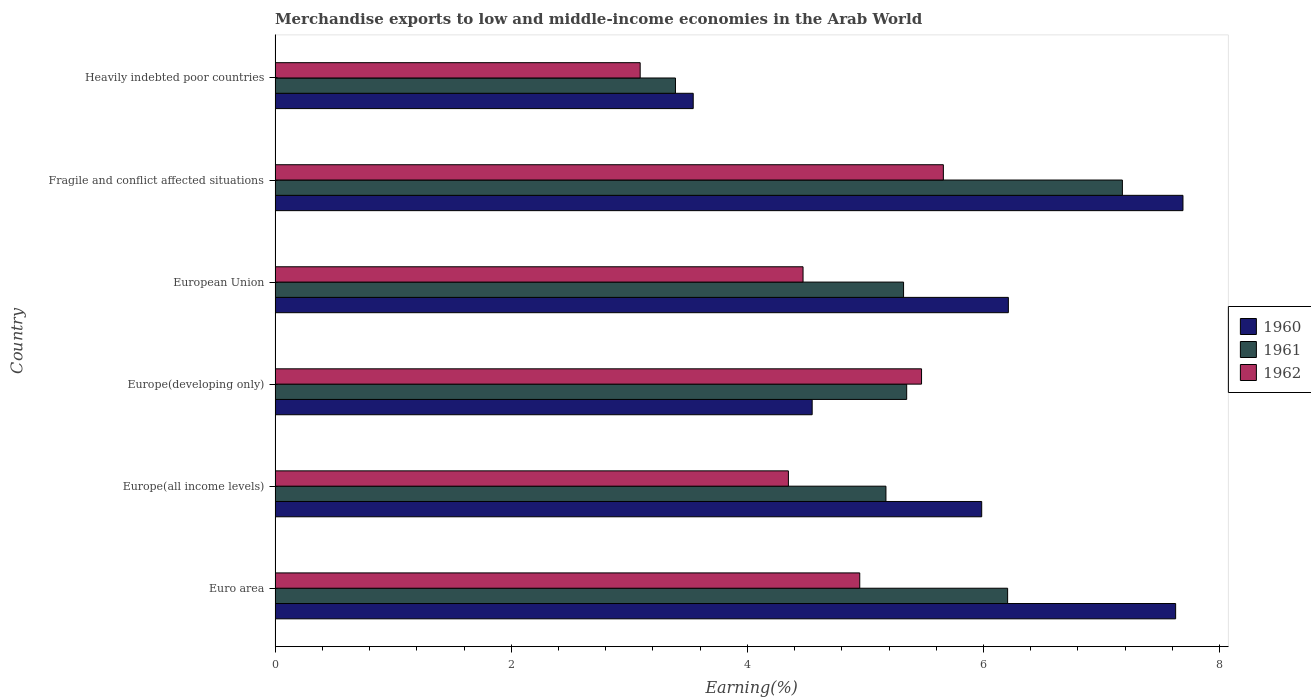How many different coloured bars are there?
Offer a terse response. 3. Are the number of bars per tick equal to the number of legend labels?
Provide a short and direct response. Yes. How many bars are there on the 1st tick from the bottom?
Keep it short and to the point. 3. What is the label of the 4th group of bars from the top?
Provide a succinct answer. Europe(developing only). In how many cases, is the number of bars for a given country not equal to the number of legend labels?
Provide a short and direct response. 0. What is the percentage of amount earned from merchandise exports in 1961 in Europe(all income levels)?
Your response must be concise. 5.17. Across all countries, what is the maximum percentage of amount earned from merchandise exports in 1961?
Keep it short and to the point. 7.18. Across all countries, what is the minimum percentage of amount earned from merchandise exports in 1960?
Offer a very short reply. 3.54. In which country was the percentage of amount earned from merchandise exports in 1960 maximum?
Your response must be concise. Fragile and conflict affected situations. In which country was the percentage of amount earned from merchandise exports in 1962 minimum?
Keep it short and to the point. Heavily indebted poor countries. What is the total percentage of amount earned from merchandise exports in 1962 in the graph?
Your response must be concise. 28. What is the difference between the percentage of amount earned from merchandise exports in 1960 in Euro area and that in Fragile and conflict affected situations?
Your answer should be very brief. -0.06. What is the difference between the percentage of amount earned from merchandise exports in 1962 in Euro area and the percentage of amount earned from merchandise exports in 1960 in European Union?
Your answer should be very brief. -1.26. What is the average percentage of amount earned from merchandise exports in 1960 per country?
Your answer should be compact. 5.93. What is the difference between the percentage of amount earned from merchandise exports in 1962 and percentage of amount earned from merchandise exports in 1961 in European Union?
Provide a short and direct response. -0.85. What is the ratio of the percentage of amount earned from merchandise exports in 1962 in Europe(developing only) to that in European Union?
Provide a succinct answer. 1.22. What is the difference between the highest and the second highest percentage of amount earned from merchandise exports in 1962?
Your response must be concise. 0.18. What is the difference between the highest and the lowest percentage of amount earned from merchandise exports in 1960?
Ensure brevity in your answer.  4.15. Is the sum of the percentage of amount earned from merchandise exports in 1961 in Euro area and Europe(all income levels) greater than the maximum percentage of amount earned from merchandise exports in 1960 across all countries?
Offer a very short reply. Yes. What does the 2nd bar from the top in Heavily indebted poor countries represents?
Ensure brevity in your answer.  1961. How many bars are there?
Ensure brevity in your answer.  18. Are all the bars in the graph horizontal?
Offer a terse response. Yes. How many countries are there in the graph?
Offer a terse response. 6. What is the difference between two consecutive major ticks on the X-axis?
Your answer should be compact. 2. Are the values on the major ticks of X-axis written in scientific E-notation?
Your answer should be compact. No. What is the title of the graph?
Make the answer very short. Merchandise exports to low and middle-income economies in the Arab World. What is the label or title of the X-axis?
Your answer should be compact. Earning(%). What is the label or title of the Y-axis?
Provide a short and direct response. Country. What is the Earning(%) of 1960 in Euro area?
Provide a short and direct response. 7.63. What is the Earning(%) in 1961 in Euro area?
Ensure brevity in your answer.  6.2. What is the Earning(%) in 1962 in Euro area?
Offer a terse response. 4.95. What is the Earning(%) of 1960 in Europe(all income levels)?
Ensure brevity in your answer.  5.98. What is the Earning(%) in 1961 in Europe(all income levels)?
Make the answer very short. 5.17. What is the Earning(%) of 1962 in Europe(all income levels)?
Your answer should be compact. 4.35. What is the Earning(%) in 1960 in Europe(developing only)?
Offer a very short reply. 4.55. What is the Earning(%) of 1961 in Europe(developing only)?
Your answer should be compact. 5.35. What is the Earning(%) of 1962 in Europe(developing only)?
Ensure brevity in your answer.  5.48. What is the Earning(%) in 1960 in European Union?
Your answer should be very brief. 6.21. What is the Earning(%) of 1961 in European Union?
Provide a short and direct response. 5.32. What is the Earning(%) in 1962 in European Union?
Give a very brief answer. 4.47. What is the Earning(%) in 1960 in Fragile and conflict affected situations?
Your answer should be compact. 7.69. What is the Earning(%) in 1961 in Fragile and conflict affected situations?
Keep it short and to the point. 7.18. What is the Earning(%) of 1962 in Fragile and conflict affected situations?
Provide a succinct answer. 5.66. What is the Earning(%) in 1960 in Heavily indebted poor countries?
Provide a succinct answer. 3.54. What is the Earning(%) in 1961 in Heavily indebted poor countries?
Provide a succinct answer. 3.39. What is the Earning(%) of 1962 in Heavily indebted poor countries?
Your answer should be compact. 3.09. Across all countries, what is the maximum Earning(%) in 1960?
Offer a terse response. 7.69. Across all countries, what is the maximum Earning(%) of 1961?
Your answer should be compact. 7.18. Across all countries, what is the maximum Earning(%) of 1962?
Provide a succinct answer. 5.66. Across all countries, what is the minimum Earning(%) in 1960?
Ensure brevity in your answer.  3.54. Across all countries, what is the minimum Earning(%) of 1961?
Provide a succinct answer. 3.39. Across all countries, what is the minimum Earning(%) in 1962?
Make the answer very short. 3.09. What is the total Earning(%) of 1960 in the graph?
Offer a terse response. 35.6. What is the total Earning(%) in 1961 in the graph?
Make the answer very short. 32.62. What is the total Earning(%) of 1962 in the graph?
Make the answer very short. 28. What is the difference between the Earning(%) of 1960 in Euro area and that in Europe(all income levels)?
Provide a short and direct response. 1.64. What is the difference between the Earning(%) in 1961 in Euro area and that in Europe(all income levels)?
Provide a short and direct response. 1.03. What is the difference between the Earning(%) in 1962 in Euro area and that in Europe(all income levels)?
Keep it short and to the point. 0.6. What is the difference between the Earning(%) in 1960 in Euro area and that in Europe(developing only)?
Provide a succinct answer. 3.08. What is the difference between the Earning(%) in 1961 in Euro area and that in Europe(developing only)?
Offer a very short reply. 0.85. What is the difference between the Earning(%) of 1962 in Euro area and that in Europe(developing only)?
Provide a succinct answer. -0.52. What is the difference between the Earning(%) of 1960 in Euro area and that in European Union?
Keep it short and to the point. 1.42. What is the difference between the Earning(%) in 1961 in Euro area and that in European Union?
Your response must be concise. 0.88. What is the difference between the Earning(%) in 1962 in Euro area and that in European Union?
Offer a terse response. 0.48. What is the difference between the Earning(%) of 1960 in Euro area and that in Fragile and conflict affected situations?
Your answer should be compact. -0.06. What is the difference between the Earning(%) of 1961 in Euro area and that in Fragile and conflict affected situations?
Your answer should be compact. -0.97. What is the difference between the Earning(%) of 1962 in Euro area and that in Fragile and conflict affected situations?
Your answer should be compact. -0.71. What is the difference between the Earning(%) in 1960 in Euro area and that in Heavily indebted poor countries?
Your answer should be very brief. 4.09. What is the difference between the Earning(%) of 1961 in Euro area and that in Heavily indebted poor countries?
Your answer should be very brief. 2.81. What is the difference between the Earning(%) of 1962 in Euro area and that in Heavily indebted poor countries?
Keep it short and to the point. 1.86. What is the difference between the Earning(%) of 1960 in Europe(all income levels) and that in Europe(developing only)?
Provide a short and direct response. 1.44. What is the difference between the Earning(%) of 1961 in Europe(all income levels) and that in Europe(developing only)?
Your answer should be compact. -0.18. What is the difference between the Earning(%) of 1962 in Europe(all income levels) and that in Europe(developing only)?
Ensure brevity in your answer.  -1.13. What is the difference between the Earning(%) in 1960 in Europe(all income levels) and that in European Union?
Offer a very short reply. -0.23. What is the difference between the Earning(%) in 1961 in Europe(all income levels) and that in European Union?
Offer a terse response. -0.15. What is the difference between the Earning(%) of 1962 in Europe(all income levels) and that in European Union?
Offer a very short reply. -0.12. What is the difference between the Earning(%) of 1960 in Europe(all income levels) and that in Fragile and conflict affected situations?
Your answer should be compact. -1.7. What is the difference between the Earning(%) of 1961 in Europe(all income levels) and that in Fragile and conflict affected situations?
Your answer should be compact. -2. What is the difference between the Earning(%) of 1962 in Europe(all income levels) and that in Fragile and conflict affected situations?
Offer a terse response. -1.31. What is the difference between the Earning(%) in 1960 in Europe(all income levels) and that in Heavily indebted poor countries?
Ensure brevity in your answer.  2.44. What is the difference between the Earning(%) of 1961 in Europe(all income levels) and that in Heavily indebted poor countries?
Your answer should be compact. 1.78. What is the difference between the Earning(%) in 1962 in Europe(all income levels) and that in Heavily indebted poor countries?
Your answer should be very brief. 1.26. What is the difference between the Earning(%) in 1960 in Europe(developing only) and that in European Union?
Provide a succinct answer. -1.66. What is the difference between the Earning(%) of 1961 in Europe(developing only) and that in European Union?
Give a very brief answer. 0.03. What is the difference between the Earning(%) in 1962 in Europe(developing only) and that in European Union?
Give a very brief answer. 1. What is the difference between the Earning(%) of 1960 in Europe(developing only) and that in Fragile and conflict affected situations?
Your answer should be compact. -3.14. What is the difference between the Earning(%) in 1961 in Europe(developing only) and that in Fragile and conflict affected situations?
Make the answer very short. -1.83. What is the difference between the Earning(%) in 1962 in Europe(developing only) and that in Fragile and conflict affected situations?
Your answer should be very brief. -0.18. What is the difference between the Earning(%) in 1960 in Europe(developing only) and that in Heavily indebted poor countries?
Ensure brevity in your answer.  1.01. What is the difference between the Earning(%) of 1961 in Europe(developing only) and that in Heavily indebted poor countries?
Your answer should be compact. 1.96. What is the difference between the Earning(%) of 1962 in Europe(developing only) and that in Heavily indebted poor countries?
Give a very brief answer. 2.38. What is the difference between the Earning(%) of 1960 in European Union and that in Fragile and conflict affected situations?
Your answer should be very brief. -1.48. What is the difference between the Earning(%) of 1961 in European Union and that in Fragile and conflict affected situations?
Keep it short and to the point. -1.85. What is the difference between the Earning(%) in 1962 in European Union and that in Fragile and conflict affected situations?
Make the answer very short. -1.19. What is the difference between the Earning(%) of 1960 in European Union and that in Heavily indebted poor countries?
Keep it short and to the point. 2.67. What is the difference between the Earning(%) of 1961 in European Union and that in Heavily indebted poor countries?
Your response must be concise. 1.93. What is the difference between the Earning(%) of 1962 in European Union and that in Heavily indebted poor countries?
Your response must be concise. 1.38. What is the difference between the Earning(%) in 1960 in Fragile and conflict affected situations and that in Heavily indebted poor countries?
Provide a succinct answer. 4.15. What is the difference between the Earning(%) in 1961 in Fragile and conflict affected situations and that in Heavily indebted poor countries?
Offer a terse response. 3.79. What is the difference between the Earning(%) of 1962 in Fragile and conflict affected situations and that in Heavily indebted poor countries?
Provide a succinct answer. 2.57. What is the difference between the Earning(%) in 1960 in Euro area and the Earning(%) in 1961 in Europe(all income levels)?
Your response must be concise. 2.45. What is the difference between the Earning(%) of 1960 in Euro area and the Earning(%) of 1962 in Europe(all income levels)?
Keep it short and to the point. 3.28. What is the difference between the Earning(%) of 1961 in Euro area and the Earning(%) of 1962 in Europe(all income levels)?
Offer a terse response. 1.86. What is the difference between the Earning(%) in 1960 in Euro area and the Earning(%) in 1961 in Europe(developing only)?
Your answer should be compact. 2.28. What is the difference between the Earning(%) of 1960 in Euro area and the Earning(%) of 1962 in Europe(developing only)?
Ensure brevity in your answer.  2.15. What is the difference between the Earning(%) of 1961 in Euro area and the Earning(%) of 1962 in Europe(developing only)?
Provide a succinct answer. 0.73. What is the difference between the Earning(%) in 1960 in Euro area and the Earning(%) in 1961 in European Union?
Provide a short and direct response. 2.3. What is the difference between the Earning(%) in 1960 in Euro area and the Earning(%) in 1962 in European Union?
Your answer should be compact. 3.16. What is the difference between the Earning(%) in 1961 in Euro area and the Earning(%) in 1962 in European Union?
Your response must be concise. 1.73. What is the difference between the Earning(%) in 1960 in Euro area and the Earning(%) in 1961 in Fragile and conflict affected situations?
Your answer should be compact. 0.45. What is the difference between the Earning(%) of 1960 in Euro area and the Earning(%) of 1962 in Fragile and conflict affected situations?
Your answer should be very brief. 1.97. What is the difference between the Earning(%) of 1961 in Euro area and the Earning(%) of 1962 in Fragile and conflict affected situations?
Keep it short and to the point. 0.54. What is the difference between the Earning(%) of 1960 in Euro area and the Earning(%) of 1961 in Heavily indebted poor countries?
Your answer should be very brief. 4.24. What is the difference between the Earning(%) in 1960 in Euro area and the Earning(%) in 1962 in Heavily indebted poor countries?
Your response must be concise. 4.54. What is the difference between the Earning(%) of 1961 in Euro area and the Earning(%) of 1962 in Heavily indebted poor countries?
Provide a short and direct response. 3.11. What is the difference between the Earning(%) of 1960 in Europe(all income levels) and the Earning(%) of 1961 in Europe(developing only)?
Your answer should be very brief. 0.64. What is the difference between the Earning(%) in 1960 in Europe(all income levels) and the Earning(%) in 1962 in Europe(developing only)?
Offer a terse response. 0.51. What is the difference between the Earning(%) of 1961 in Europe(all income levels) and the Earning(%) of 1962 in Europe(developing only)?
Offer a very short reply. -0.3. What is the difference between the Earning(%) of 1960 in Europe(all income levels) and the Earning(%) of 1961 in European Union?
Your response must be concise. 0.66. What is the difference between the Earning(%) of 1960 in Europe(all income levels) and the Earning(%) of 1962 in European Union?
Provide a short and direct response. 1.51. What is the difference between the Earning(%) of 1961 in Europe(all income levels) and the Earning(%) of 1962 in European Union?
Provide a succinct answer. 0.7. What is the difference between the Earning(%) in 1960 in Europe(all income levels) and the Earning(%) in 1961 in Fragile and conflict affected situations?
Your answer should be very brief. -1.19. What is the difference between the Earning(%) of 1960 in Europe(all income levels) and the Earning(%) of 1962 in Fragile and conflict affected situations?
Give a very brief answer. 0.32. What is the difference between the Earning(%) of 1961 in Europe(all income levels) and the Earning(%) of 1962 in Fragile and conflict affected situations?
Ensure brevity in your answer.  -0.49. What is the difference between the Earning(%) of 1960 in Europe(all income levels) and the Earning(%) of 1961 in Heavily indebted poor countries?
Keep it short and to the point. 2.59. What is the difference between the Earning(%) of 1960 in Europe(all income levels) and the Earning(%) of 1962 in Heavily indebted poor countries?
Your answer should be very brief. 2.89. What is the difference between the Earning(%) in 1961 in Europe(all income levels) and the Earning(%) in 1962 in Heavily indebted poor countries?
Give a very brief answer. 2.08. What is the difference between the Earning(%) of 1960 in Europe(developing only) and the Earning(%) of 1961 in European Union?
Your response must be concise. -0.77. What is the difference between the Earning(%) of 1960 in Europe(developing only) and the Earning(%) of 1962 in European Union?
Ensure brevity in your answer.  0.08. What is the difference between the Earning(%) of 1961 in Europe(developing only) and the Earning(%) of 1962 in European Union?
Make the answer very short. 0.88. What is the difference between the Earning(%) in 1960 in Europe(developing only) and the Earning(%) in 1961 in Fragile and conflict affected situations?
Give a very brief answer. -2.63. What is the difference between the Earning(%) of 1960 in Europe(developing only) and the Earning(%) of 1962 in Fragile and conflict affected situations?
Your answer should be compact. -1.11. What is the difference between the Earning(%) of 1961 in Europe(developing only) and the Earning(%) of 1962 in Fragile and conflict affected situations?
Keep it short and to the point. -0.31. What is the difference between the Earning(%) of 1960 in Europe(developing only) and the Earning(%) of 1961 in Heavily indebted poor countries?
Your response must be concise. 1.16. What is the difference between the Earning(%) in 1960 in Europe(developing only) and the Earning(%) in 1962 in Heavily indebted poor countries?
Keep it short and to the point. 1.46. What is the difference between the Earning(%) of 1961 in Europe(developing only) and the Earning(%) of 1962 in Heavily indebted poor countries?
Ensure brevity in your answer.  2.26. What is the difference between the Earning(%) of 1960 in European Union and the Earning(%) of 1961 in Fragile and conflict affected situations?
Give a very brief answer. -0.97. What is the difference between the Earning(%) of 1960 in European Union and the Earning(%) of 1962 in Fragile and conflict affected situations?
Ensure brevity in your answer.  0.55. What is the difference between the Earning(%) in 1961 in European Union and the Earning(%) in 1962 in Fragile and conflict affected situations?
Offer a terse response. -0.34. What is the difference between the Earning(%) in 1960 in European Union and the Earning(%) in 1961 in Heavily indebted poor countries?
Your answer should be compact. 2.82. What is the difference between the Earning(%) of 1960 in European Union and the Earning(%) of 1962 in Heavily indebted poor countries?
Offer a very short reply. 3.12. What is the difference between the Earning(%) in 1961 in European Union and the Earning(%) in 1962 in Heavily indebted poor countries?
Offer a terse response. 2.23. What is the difference between the Earning(%) of 1960 in Fragile and conflict affected situations and the Earning(%) of 1961 in Heavily indebted poor countries?
Offer a very short reply. 4.3. What is the difference between the Earning(%) of 1960 in Fragile and conflict affected situations and the Earning(%) of 1962 in Heavily indebted poor countries?
Offer a very short reply. 4.6. What is the difference between the Earning(%) of 1961 in Fragile and conflict affected situations and the Earning(%) of 1962 in Heavily indebted poor countries?
Make the answer very short. 4.08. What is the average Earning(%) of 1960 per country?
Offer a very short reply. 5.93. What is the average Earning(%) in 1961 per country?
Give a very brief answer. 5.44. What is the average Earning(%) in 1962 per country?
Offer a very short reply. 4.67. What is the difference between the Earning(%) in 1960 and Earning(%) in 1961 in Euro area?
Make the answer very short. 1.42. What is the difference between the Earning(%) of 1960 and Earning(%) of 1962 in Euro area?
Your answer should be compact. 2.68. What is the difference between the Earning(%) of 1961 and Earning(%) of 1962 in Euro area?
Keep it short and to the point. 1.25. What is the difference between the Earning(%) of 1960 and Earning(%) of 1961 in Europe(all income levels)?
Keep it short and to the point. 0.81. What is the difference between the Earning(%) in 1960 and Earning(%) in 1962 in Europe(all income levels)?
Provide a short and direct response. 1.64. What is the difference between the Earning(%) in 1961 and Earning(%) in 1962 in Europe(all income levels)?
Your response must be concise. 0.83. What is the difference between the Earning(%) in 1960 and Earning(%) in 1961 in Europe(developing only)?
Provide a short and direct response. -0.8. What is the difference between the Earning(%) of 1960 and Earning(%) of 1962 in Europe(developing only)?
Offer a very short reply. -0.93. What is the difference between the Earning(%) of 1961 and Earning(%) of 1962 in Europe(developing only)?
Provide a short and direct response. -0.13. What is the difference between the Earning(%) of 1960 and Earning(%) of 1961 in European Union?
Your response must be concise. 0.89. What is the difference between the Earning(%) in 1960 and Earning(%) in 1962 in European Union?
Keep it short and to the point. 1.74. What is the difference between the Earning(%) in 1961 and Earning(%) in 1962 in European Union?
Ensure brevity in your answer.  0.85. What is the difference between the Earning(%) of 1960 and Earning(%) of 1961 in Fragile and conflict affected situations?
Offer a terse response. 0.51. What is the difference between the Earning(%) of 1960 and Earning(%) of 1962 in Fragile and conflict affected situations?
Ensure brevity in your answer.  2.03. What is the difference between the Earning(%) in 1961 and Earning(%) in 1962 in Fragile and conflict affected situations?
Keep it short and to the point. 1.52. What is the difference between the Earning(%) in 1960 and Earning(%) in 1961 in Heavily indebted poor countries?
Offer a very short reply. 0.15. What is the difference between the Earning(%) of 1960 and Earning(%) of 1962 in Heavily indebted poor countries?
Your response must be concise. 0.45. What is the difference between the Earning(%) of 1961 and Earning(%) of 1962 in Heavily indebted poor countries?
Give a very brief answer. 0.3. What is the ratio of the Earning(%) of 1960 in Euro area to that in Europe(all income levels)?
Your answer should be very brief. 1.27. What is the ratio of the Earning(%) in 1961 in Euro area to that in Europe(all income levels)?
Offer a terse response. 1.2. What is the ratio of the Earning(%) of 1962 in Euro area to that in Europe(all income levels)?
Your response must be concise. 1.14. What is the ratio of the Earning(%) of 1960 in Euro area to that in Europe(developing only)?
Provide a succinct answer. 1.68. What is the ratio of the Earning(%) in 1961 in Euro area to that in Europe(developing only)?
Give a very brief answer. 1.16. What is the ratio of the Earning(%) in 1962 in Euro area to that in Europe(developing only)?
Your answer should be very brief. 0.9. What is the ratio of the Earning(%) of 1960 in Euro area to that in European Union?
Offer a terse response. 1.23. What is the ratio of the Earning(%) in 1961 in Euro area to that in European Union?
Your answer should be compact. 1.17. What is the ratio of the Earning(%) in 1962 in Euro area to that in European Union?
Offer a terse response. 1.11. What is the ratio of the Earning(%) of 1961 in Euro area to that in Fragile and conflict affected situations?
Provide a succinct answer. 0.86. What is the ratio of the Earning(%) in 1962 in Euro area to that in Fragile and conflict affected situations?
Your response must be concise. 0.87. What is the ratio of the Earning(%) of 1960 in Euro area to that in Heavily indebted poor countries?
Provide a succinct answer. 2.15. What is the ratio of the Earning(%) in 1961 in Euro area to that in Heavily indebted poor countries?
Make the answer very short. 1.83. What is the ratio of the Earning(%) in 1962 in Euro area to that in Heavily indebted poor countries?
Your answer should be compact. 1.6. What is the ratio of the Earning(%) of 1960 in Europe(all income levels) to that in Europe(developing only)?
Provide a succinct answer. 1.32. What is the ratio of the Earning(%) in 1961 in Europe(all income levels) to that in Europe(developing only)?
Make the answer very short. 0.97. What is the ratio of the Earning(%) in 1962 in Europe(all income levels) to that in Europe(developing only)?
Your answer should be very brief. 0.79. What is the ratio of the Earning(%) of 1960 in Europe(all income levels) to that in European Union?
Provide a short and direct response. 0.96. What is the ratio of the Earning(%) of 1961 in Europe(all income levels) to that in European Union?
Your response must be concise. 0.97. What is the ratio of the Earning(%) of 1962 in Europe(all income levels) to that in European Union?
Provide a short and direct response. 0.97. What is the ratio of the Earning(%) of 1960 in Europe(all income levels) to that in Fragile and conflict affected situations?
Your answer should be compact. 0.78. What is the ratio of the Earning(%) in 1961 in Europe(all income levels) to that in Fragile and conflict affected situations?
Make the answer very short. 0.72. What is the ratio of the Earning(%) in 1962 in Europe(all income levels) to that in Fragile and conflict affected situations?
Your response must be concise. 0.77. What is the ratio of the Earning(%) of 1960 in Europe(all income levels) to that in Heavily indebted poor countries?
Ensure brevity in your answer.  1.69. What is the ratio of the Earning(%) of 1961 in Europe(all income levels) to that in Heavily indebted poor countries?
Ensure brevity in your answer.  1.53. What is the ratio of the Earning(%) of 1962 in Europe(all income levels) to that in Heavily indebted poor countries?
Provide a succinct answer. 1.41. What is the ratio of the Earning(%) in 1960 in Europe(developing only) to that in European Union?
Keep it short and to the point. 0.73. What is the ratio of the Earning(%) of 1962 in Europe(developing only) to that in European Union?
Make the answer very short. 1.22. What is the ratio of the Earning(%) of 1960 in Europe(developing only) to that in Fragile and conflict affected situations?
Offer a very short reply. 0.59. What is the ratio of the Earning(%) of 1961 in Europe(developing only) to that in Fragile and conflict affected situations?
Provide a succinct answer. 0.75. What is the ratio of the Earning(%) in 1962 in Europe(developing only) to that in Fragile and conflict affected situations?
Offer a very short reply. 0.97. What is the ratio of the Earning(%) in 1960 in Europe(developing only) to that in Heavily indebted poor countries?
Give a very brief answer. 1.28. What is the ratio of the Earning(%) in 1961 in Europe(developing only) to that in Heavily indebted poor countries?
Offer a very short reply. 1.58. What is the ratio of the Earning(%) in 1962 in Europe(developing only) to that in Heavily indebted poor countries?
Make the answer very short. 1.77. What is the ratio of the Earning(%) of 1960 in European Union to that in Fragile and conflict affected situations?
Ensure brevity in your answer.  0.81. What is the ratio of the Earning(%) of 1961 in European Union to that in Fragile and conflict affected situations?
Give a very brief answer. 0.74. What is the ratio of the Earning(%) of 1962 in European Union to that in Fragile and conflict affected situations?
Your response must be concise. 0.79. What is the ratio of the Earning(%) of 1960 in European Union to that in Heavily indebted poor countries?
Provide a succinct answer. 1.75. What is the ratio of the Earning(%) of 1961 in European Union to that in Heavily indebted poor countries?
Keep it short and to the point. 1.57. What is the ratio of the Earning(%) of 1962 in European Union to that in Heavily indebted poor countries?
Ensure brevity in your answer.  1.45. What is the ratio of the Earning(%) in 1960 in Fragile and conflict affected situations to that in Heavily indebted poor countries?
Give a very brief answer. 2.17. What is the ratio of the Earning(%) of 1961 in Fragile and conflict affected situations to that in Heavily indebted poor countries?
Provide a succinct answer. 2.12. What is the ratio of the Earning(%) of 1962 in Fragile and conflict affected situations to that in Heavily indebted poor countries?
Give a very brief answer. 1.83. What is the difference between the highest and the second highest Earning(%) of 1960?
Offer a very short reply. 0.06. What is the difference between the highest and the second highest Earning(%) in 1962?
Provide a short and direct response. 0.18. What is the difference between the highest and the lowest Earning(%) in 1960?
Your answer should be very brief. 4.15. What is the difference between the highest and the lowest Earning(%) in 1961?
Ensure brevity in your answer.  3.79. What is the difference between the highest and the lowest Earning(%) of 1962?
Your response must be concise. 2.57. 